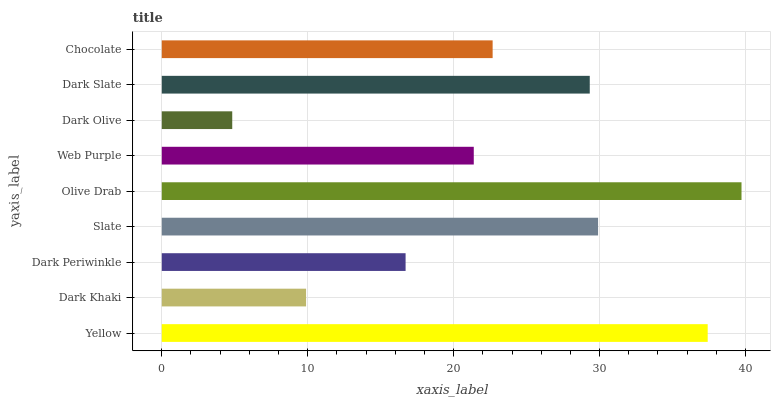Is Dark Olive the minimum?
Answer yes or no. Yes. Is Olive Drab the maximum?
Answer yes or no. Yes. Is Dark Khaki the minimum?
Answer yes or no. No. Is Dark Khaki the maximum?
Answer yes or no. No. Is Yellow greater than Dark Khaki?
Answer yes or no. Yes. Is Dark Khaki less than Yellow?
Answer yes or no. Yes. Is Dark Khaki greater than Yellow?
Answer yes or no. No. Is Yellow less than Dark Khaki?
Answer yes or no. No. Is Chocolate the high median?
Answer yes or no. Yes. Is Chocolate the low median?
Answer yes or no. Yes. Is Slate the high median?
Answer yes or no. No. Is Dark Khaki the low median?
Answer yes or no. No. 